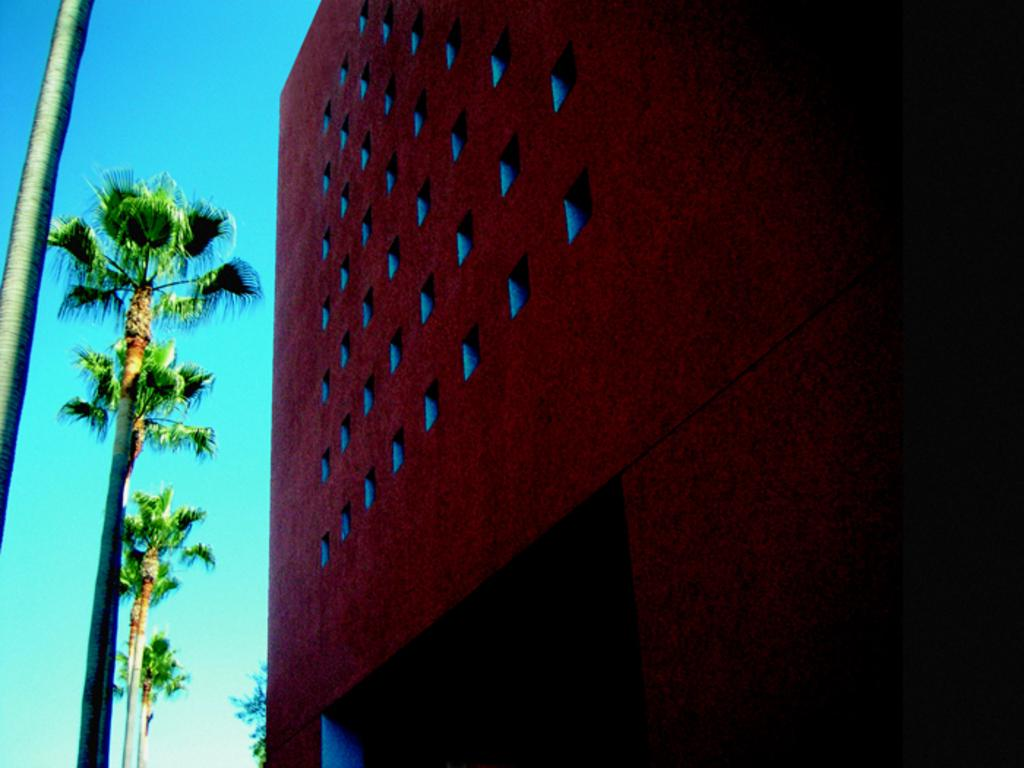What type of structure is present in the image? There is a building in the image. What architectural features can be seen on the building? The building has windows and pillars. What other elements are present in the image besides the building? There are trees and the sky is visible in the image. Can you describe the appearance of the image? The image appears to be an edited photo. How many tomatoes are being rubbed on the sidewalk in the image? There are no tomatoes or sidewalks present in the image. 